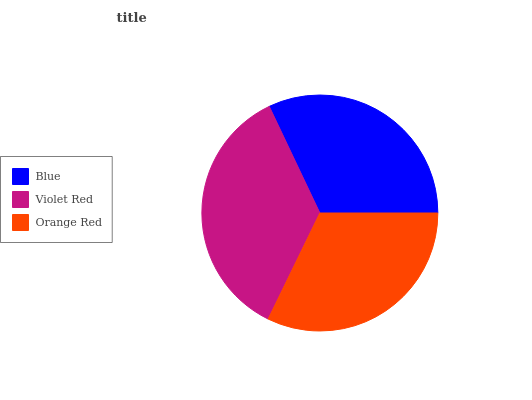Is Blue the minimum?
Answer yes or no. Yes. Is Violet Red the maximum?
Answer yes or no. Yes. Is Orange Red the minimum?
Answer yes or no. No. Is Orange Red the maximum?
Answer yes or no. No. Is Violet Red greater than Orange Red?
Answer yes or no. Yes. Is Orange Red less than Violet Red?
Answer yes or no. Yes. Is Orange Red greater than Violet Red?
Answer yes or no. No. Is Violet Red less than Orange Red?
Answer yes or no. No. Is Orange Red the high median?
Answer yes or no. Yes. Is Orange Red the low median?
Answer yes or no. Yes. Is Blue the high median?
Answer yes or no. No. Is Violet Red the low median?
Answer yes or no. No. 